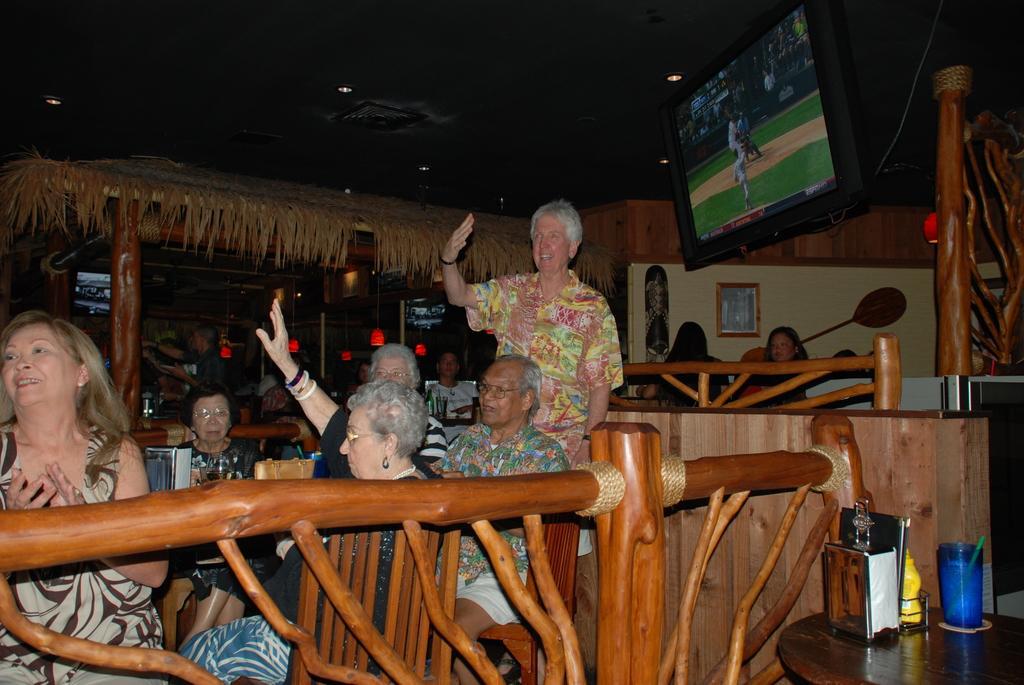In one or two sentences, can you explain what this image depicts? The picture is come a restaurant. in the center of the picture there are few people seated in chairs. In the foreground there is railing. On the right there is a table, on the table there are glasses, packets, cards and some boxes. On the top right there is a television is center a man is standing. In the foreground there are lights and televisions. This is a thatched hut. In is center of the background there is a wall, on the wall there is a frame. 